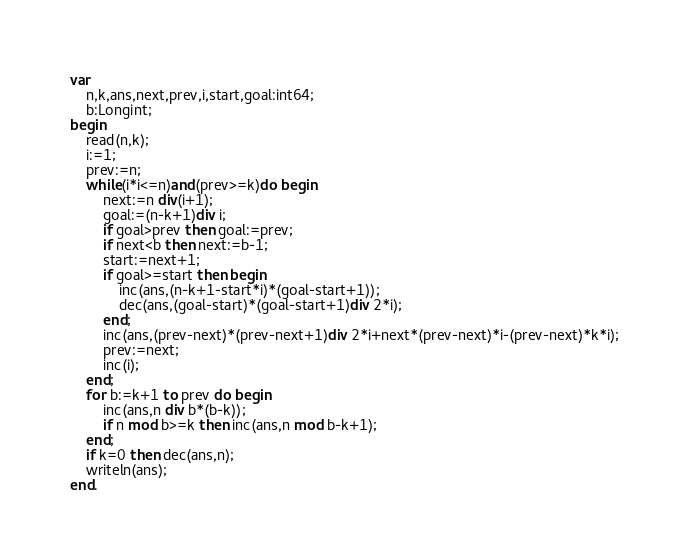Convert code to text. <code><loc_0><loc_0><loc_500><loc_500><_Pascal_>var
	n,k,ans,next,prev,i,start,goal:int64;
	b:Longint;
begin
	read(n,k);
	i:=1;
	prev:=n;
	while(i*i<=n)and(prev>=k)do begin
		next:=n div(i+1);
		goal:=(n-k+1)div i;
		if goal>prev then goal:=prev;
		if next<b then next:=b-1;
		start:=next+1;
		if goal>=start then begin
			inc(ans,(n-k+1-start*i)*(goal-start+1));
			dec(ans,(goal-start)*(goal-start+1)div 2*i);
		end;
		inc(ans,(prev-next)*(prev-next+1)div 2*i+next*(prev-next)*i-(prev-next)*k*i);
		prev:=next;
		inc(i);
	end;
	for b:=k+1 to prev do begin
		inc(ans,n div b*(b-k));
		if n mod b>=k then inc(ans,n mod b-k+1);
	end;
	if k=0 then dec(ans,n);
	writeln(ans);
end.</code> 